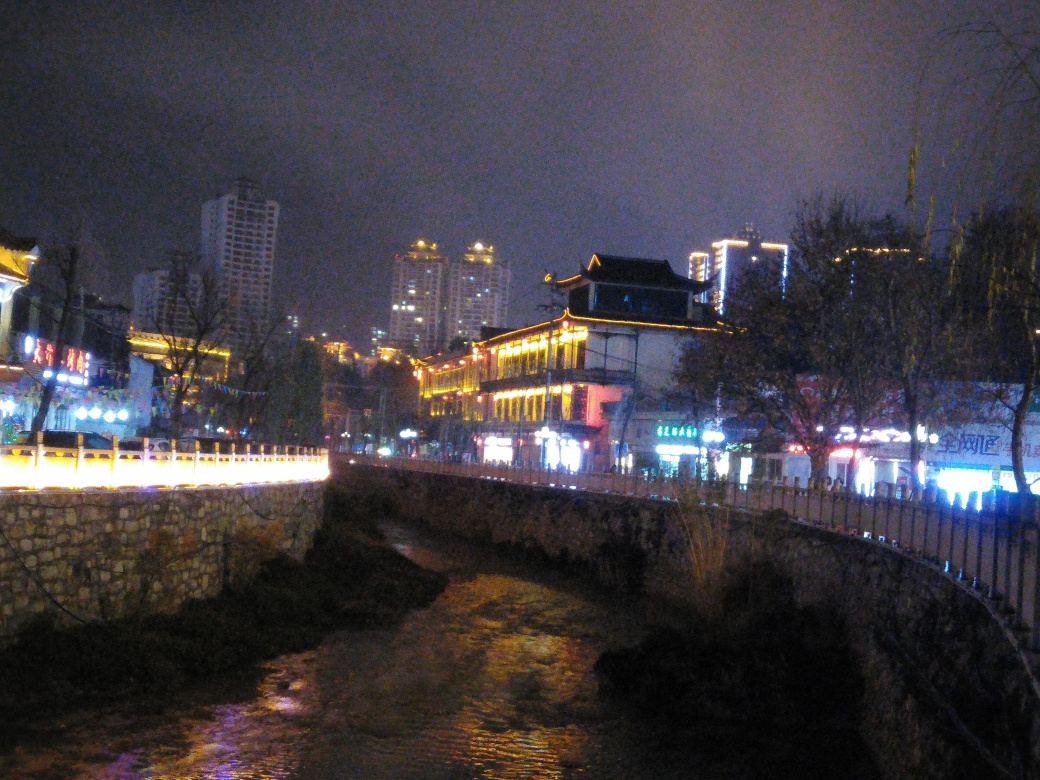Describe the architectural style of the ancient building seen in the image. The architecture of the building displayed bears the hallmarks of traditional East Asian design. It features a prominent roof with upward-curving eaves, indicative of classical Chinese construction, often seen in historic temples and palaces. The intricate decorative elements and the overall balance of the structure suggest respectful adherence to the principles of harmony and symmetry, which are deeply rooted in the region's architectural ethos. 